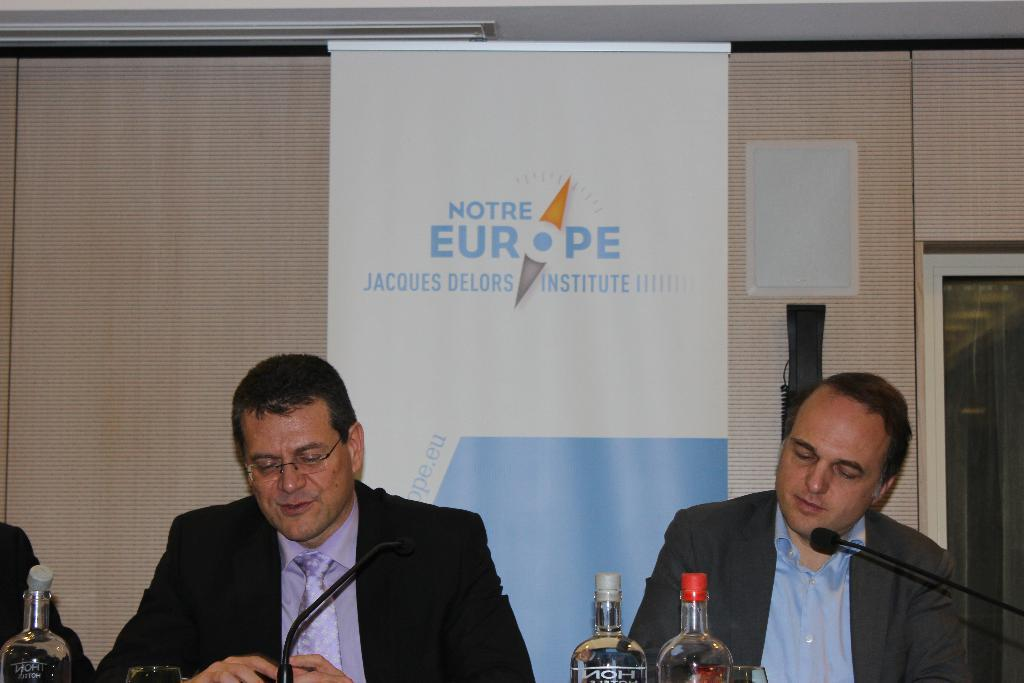<image>
Present a compact description of the photo's key features. A man sits and talks into a microphone at a Notre Europe event while another man sits beside him. 